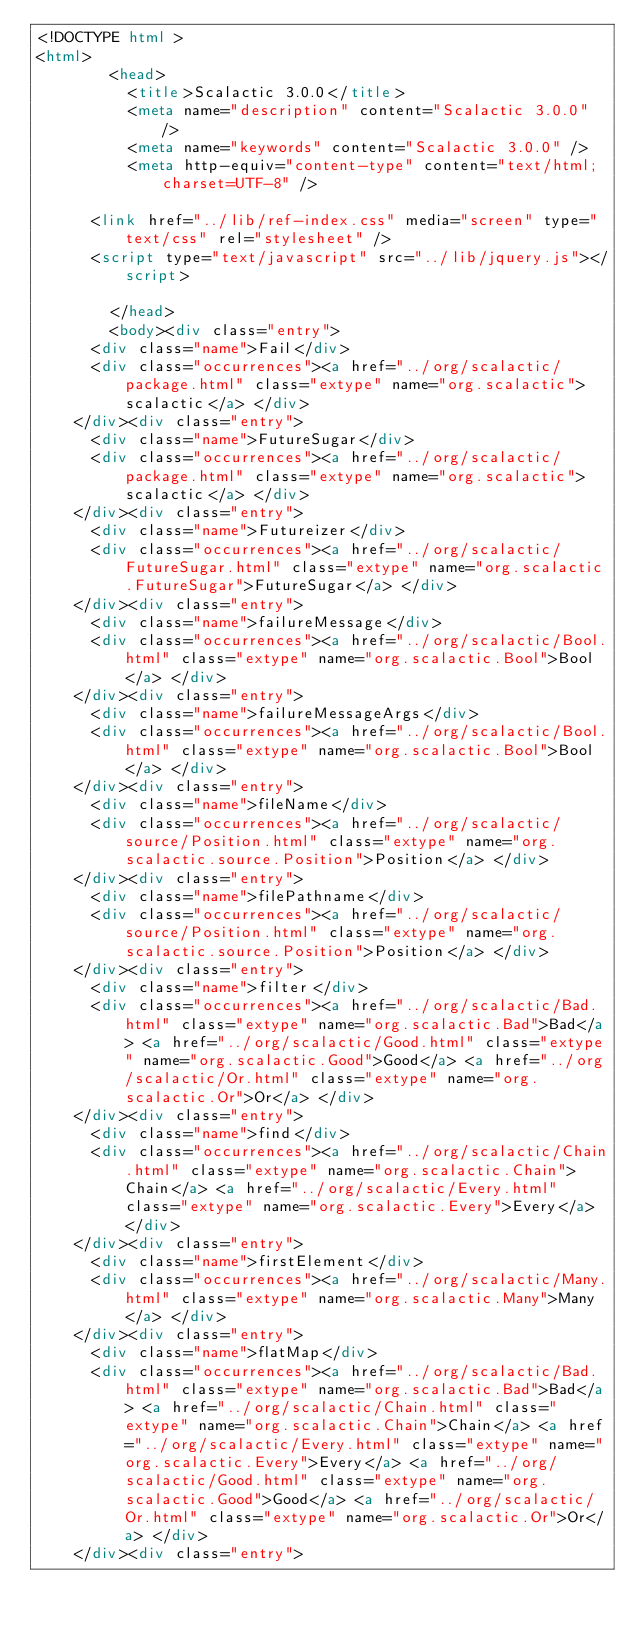Convert code to text. <code><loc_0><loc_0><loc_500><loc_500><_HTML_><!DOCTYPE html >
<html>
        <head>
          <title>Scalactic 3.0.0</title>
          <meta name="description" content="Scalactic 3.0.0" />
          <meta name="keywords" content="Scalactic 3.0.0" />
          <meta http-equiv="content-type" content="text/html; charset=UTF-8" />
          
      <link href="../lib/ref-index.css" media="screen" type="text/css" rel="stylesheet" />
      <script type="text/javascript" src="../lib/jquery.js"></script>
    
        </head>
        <body><div class="entry">
      <div class="name">Fail</div>
      <div class="occurrences"><a href="../org/scalactic/package.html" class="extype" name="org.scalactic">scalactic</a> </div>
    </div><div class="entry">
      <div class="name">FutureSugar</div>
      <div class="occurrences"><a href="../org/scalactic/package.html" class="extype" name="org.scalactic">scalactic</a> </div>
    </div><div class="entry">
      <div class="name">Futureizer</div>
      <div class="occurrences"><a href="../org/scalactic/FutureSugar.html" class="extype" name="org.scalactic.FutureSugar">FutureSugar</a> </div>
    </div><div class="entry">
      <div class="name">failureMessage</div>
      <div class="occurrences"><a href="../org/scalactic/Bool.html" class="extype" name="org.scalactic.Bool">Bool</a> </div>
    </div><div class="entry">
      <div class="name">failureMessageArgs</div>
      <div class="occurrences"><a href="../org/scalactic/Bool.html" class="extype" name="org.scalactic.Bool">Bool</a> </div>
    </div><div class="entry">
      <div class="name">fileName</div>
      <div class="occurrences"><a href="../org/scalactic/source/Position.html" class="extype" name="org.scalactic.source.Position">Position</a> </div>
    </div><div class="entry">
      <div class="name">filePathname</div>
      <div class="occurrences"><a href="../org/scalactic/source/Position.html" class="extype" name="org.scalactic.source.Position">Position</a> </div>
    </div><div class="entry">
      <div class="name">filter</div>
      <div class="occurrences"><a href="../org/scalactic/Bad.html" class="extype" name="org.scalactic.Bad">Bad</a> <a href="../org/scalactic/Good.html" class="extype" name="org.scalactic.Good">Good</a> <a href="../org/scalactic/Or.html" class="extype" name="org.scalactic.Or">Or</a> </div>
    </div><div class="entry">
      <div class="name">find</div>
      <div class="occurrences"><a href="../org/scalactic/Chain.html" class="extype" name="org.scalactic.Chain">Chain</a> <a href="../org/scalactic/Every.html" class="extype" name="org.scalactic.Every">Every</a> </div>
    </div><div class="entry">
      <div class="name">firstElement</div>
      <div class="occurrences"><a href="../org/scalactic/Many.html" class="extype" name="org.scalactic.Many">Many</a> </div>
    </div><div class="entry">
      <div class="name">flatMap</div>
      <div class="occurrences"><a href="../org/scalactic/Bad.html" class="extype" name="org.scalactic.Bad">Bad</a> <a href="../org/scalactic/Chain.html" class="extype" name="org.scalactic.Chain">Chain</a> <a href="../org/scalactic/Every.html" class="extype" name="org.scalactic.Every">Every</a> <a href="../org/scalactic/Good.html" class="extype" name="org.scalactic.Good">Good</a> <a href="../org/scalactic/Or.html" class="extype" name="org.scalactic.Or">Or</a> </div>
    </div><div class="entry"></code> 